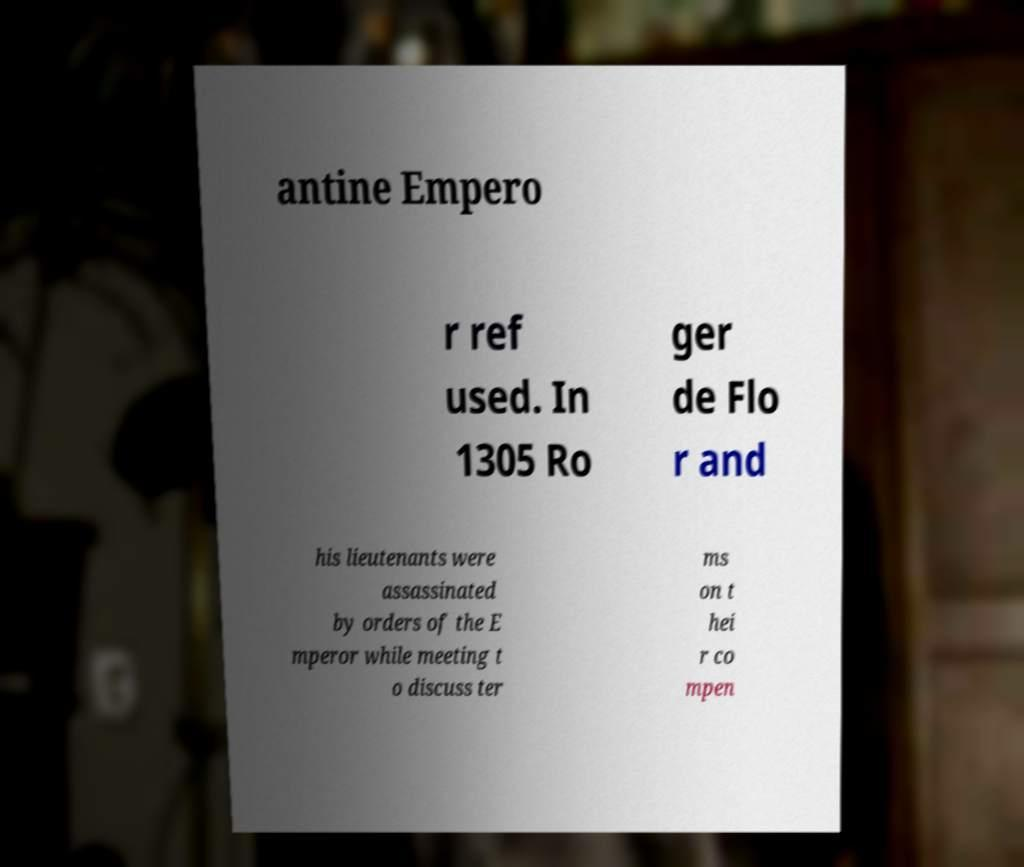Can you read and provide the text displayed in the image?This photo seems to have some interesting text. Can you extract and type it out for me? antine Empero r ref used. In 1305 Ro ger de Flo r and his lieutenants were assassinated by orders of the E mperor while meeting t o discuss ter ms on t hei r co mpen 